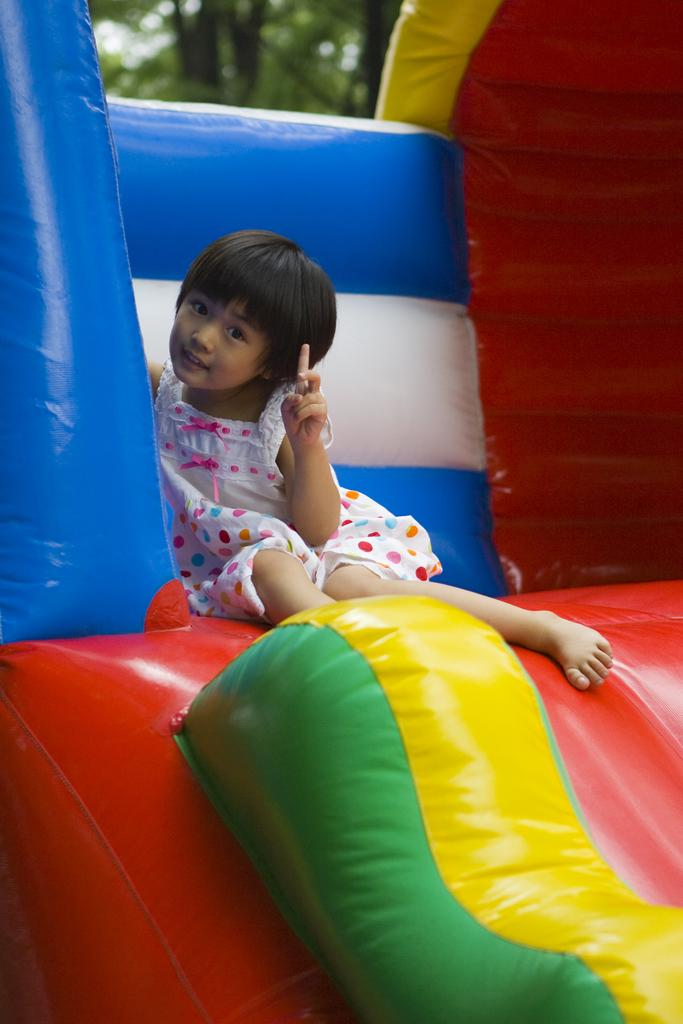What is the main subject of the image? The main subject of the image is a kid. What is the kid sitting on? The kid is sitting on an inflatable tube. What can be seen in the background of the image? There is a tree in the background of the image. What type of food is the kid eating while sitting on the inflatable tube? There is no food visible in the image, so it cannot be determined what the kid might be eating. 